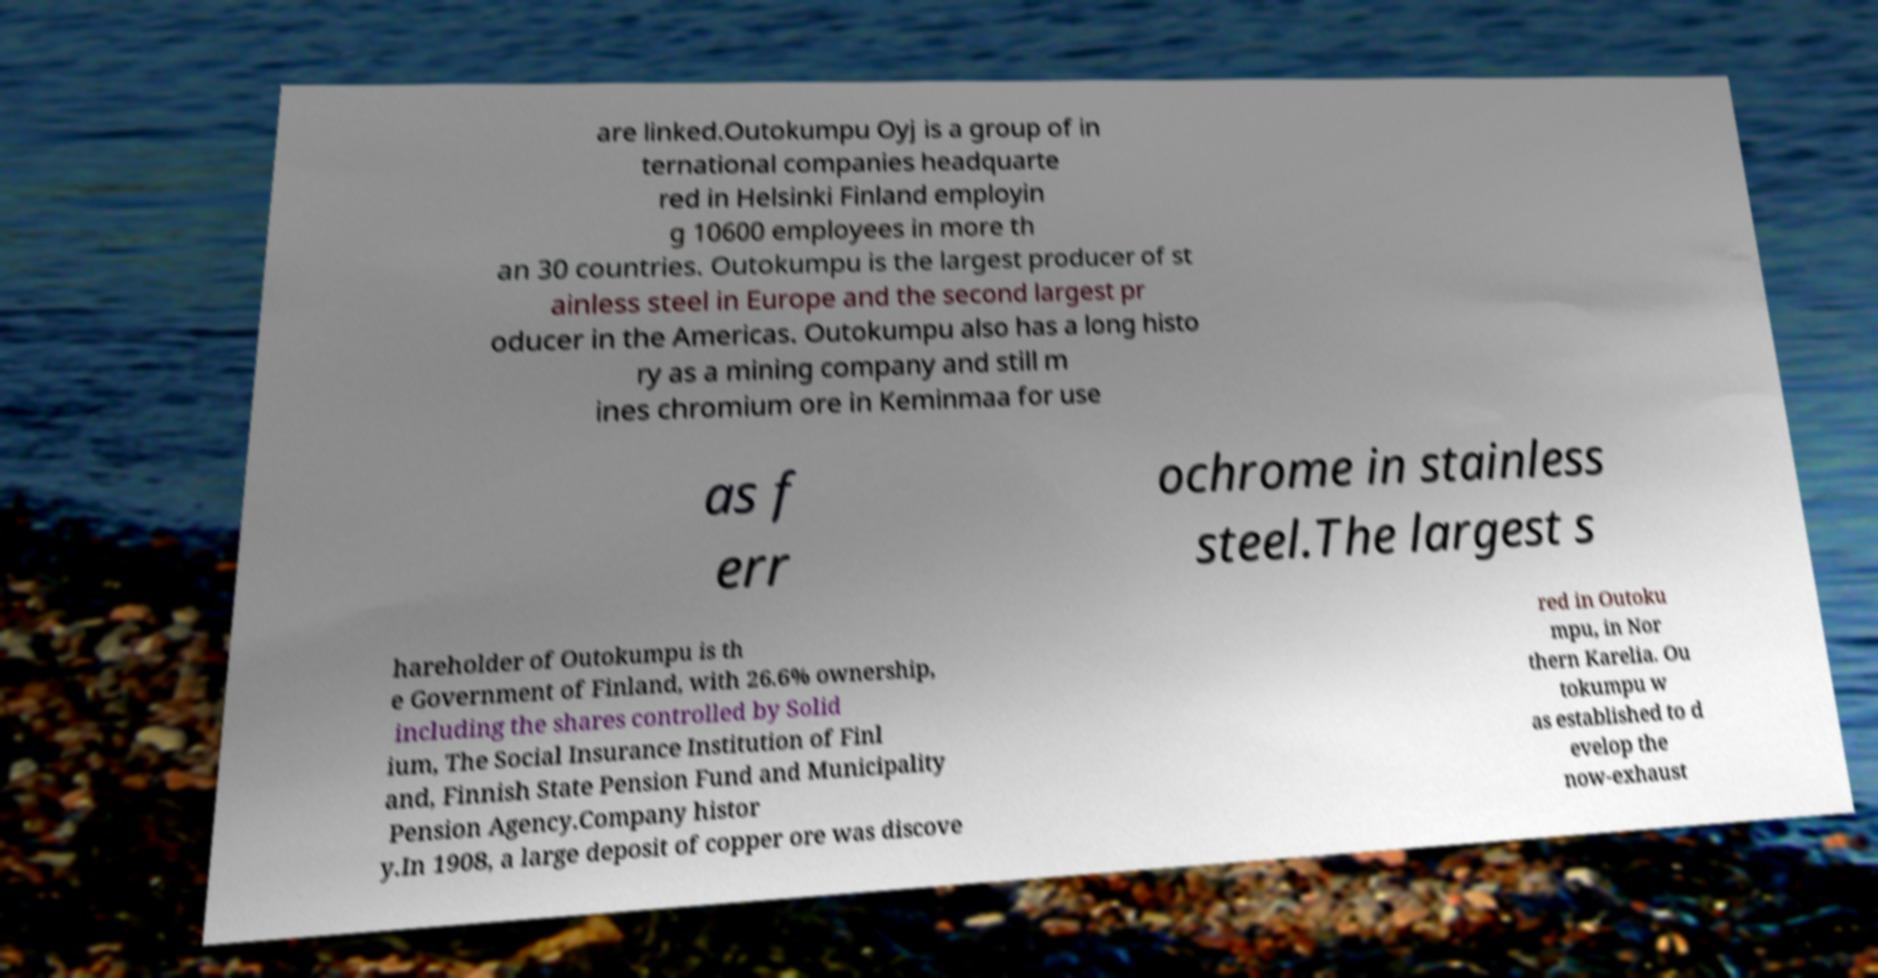What messages or text are displayed in this image? I need them in a readable, typed format. are linked.Outokumpu Oyj is a group of in ternational companies headquarte red in Helsinki Finland employin g 10600 employees in more th an 30 countries. Outokumpu is the largest producer of st ainless steel in Europe and the second largest pr oducer in the Americas. Outokumpu also has a long histo ry as a mining company and still m ines chromium ore in Keminmaa for use as f err ochrome in stainless steel.The largest s hareholder of Outokumpu is th e Government of Finland, with 26.6% ownership, including the shares controlled by Solid ium, The Social Insurance Institution of Finl and, Finnish State Pension Fund and Municipality Pension Agency.Company histor y.In 1908, a large deposit of copper ore was discove red in Outoku mpu, in Nor thern Karelia. Ou tokumpu w as established to d evelop the now-exhaust 